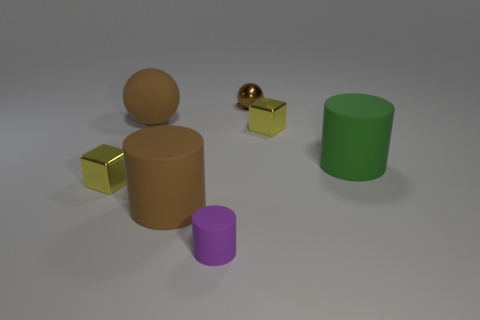There is a big green rubber object; how many yellow metal cubes are on the right side of it?
Ensure brevity in your answer.  0. Is the color of the small metallic sphere the same as the tiny cylinder?
Offer a terse response. No. The small purple object that is made of the same material as the big green object is what shape?
Offer a terse response. Cylinder. There is a large green object to the right of the small brown ball; is it the same shape as the tiny brown shiny object?
Give a very brief answer. No. What number of yellow things are either metallic blocks or balls?
Provide a short and direct response. 2. Are there the same number of tiny metal blocks and small brown metallic balls?
Give a very brief answer. No. Are there the same number of brown matte cylinders that are right of the small purple thing and small purple rubber objects that are to the right of the large green rubber object?
Provide a short and direct response. Yes. The shiny block that is behind the small yellow thing to the left of the tiny yellow metal block to the right of the purple matte cylinder is what color?
Keep it short and to the point. Yellow. Is there anything else that has the same color as the tiny cylinder?
Make the answer very short. No. There is a large object that is the same color as the matte sphere; what shape is it?
Provide a succinct answer. Cylinder. 